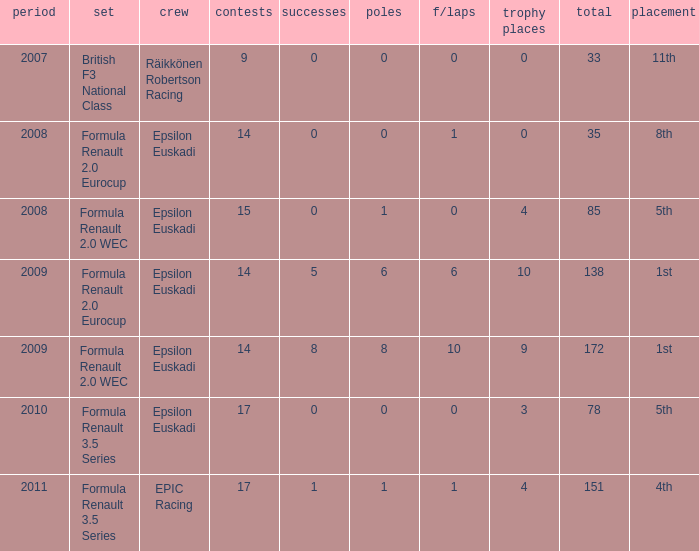What team was he on when he finished in 11th position? Räikkönen Robertson Racing. 